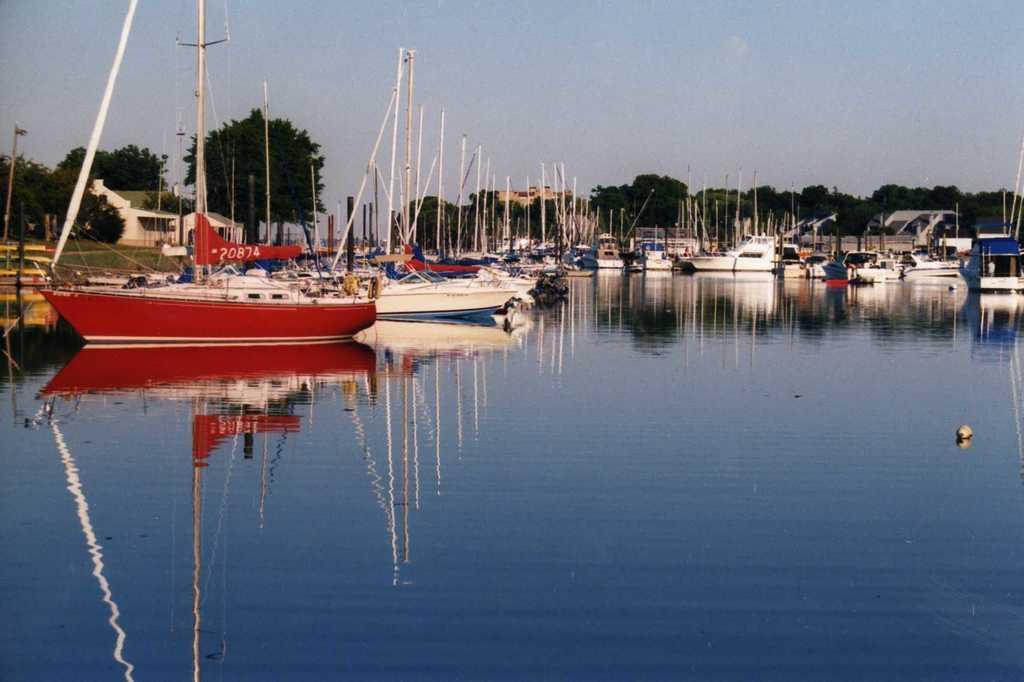How would you summarize this image in a sentence or two? We can see ships above the water and we can see poles and banner. In the background we can see trees, houses, grass and sky. 